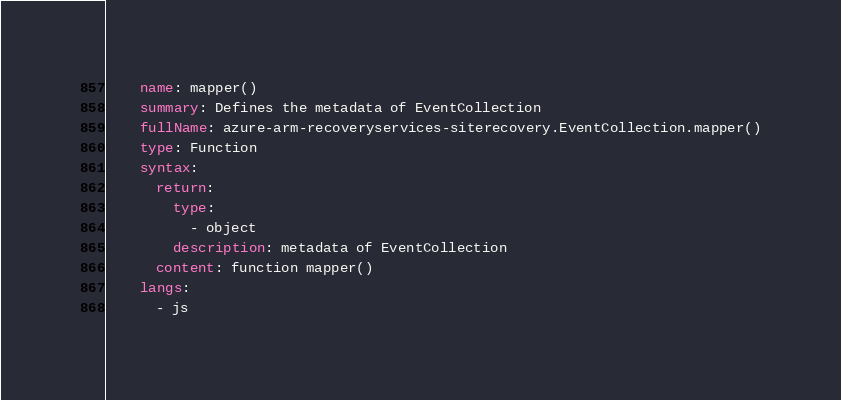Convert code to text. <code><loc_0><loc_0><loc_500><loc_500><_YAML_>    name: mapper()
    summary: Defines the metadata of EventCollection
    fullName: azure-arm-recoveryservices-siterecovery.EventCollection.mapper()
    type: Function
    syntax:
      return:
        type:
          - object
        description: metadata of EventCollection
      content: function mapper()
    langs:
      - js
</code> 